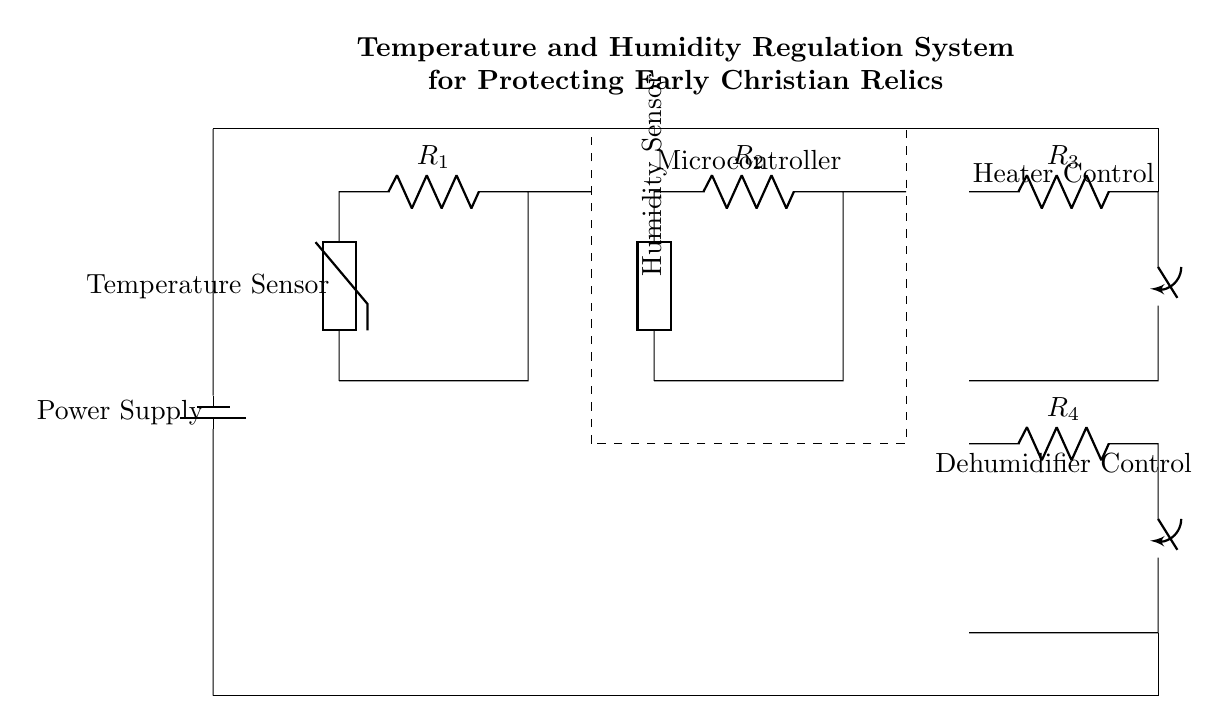What is the purpose of the temperature sensor? The temperature sensor's purpose is to monitor the ambient temperature to ensure proper conditions for the preservation of relics. It is connected to the microcontroller, which processes its data and controls the heater if necessary.
Answer: Monitor temperature What type of component is used for humidity sensing? The circuit diagram shows a generic component for humidity sensing. It is typically a hygrometer or similar device that detects moisture levels in the environment.
Answer: Generic How many resistors are in this circuit diagram? There are four resistors labeled as R1, R2, R3, and R4. This includes both temperature and humidity sensors and controls for the heater and dehumidifier.
Answer: Four What does the microcontroller do in this circuit? The microcontroller acts as the central processing unit, receiving data from the temperature and humidity sensors, then making decisions to activate either the heater or the dehumidifier based on the environmental conditions.
Answer: Process data What is the role of R3 in this circuit? R3 is connected to the heater control, allowing it to regulate temperature by turning the heater on or off based on the inputs from the microcontroller.
Answer: Heater control What type of circuit is this? This circuit is a temperature and humidity regulation system used to protect sensitive materials, such as early Christian relics, from environmental damage.
Answer: Regulation system 